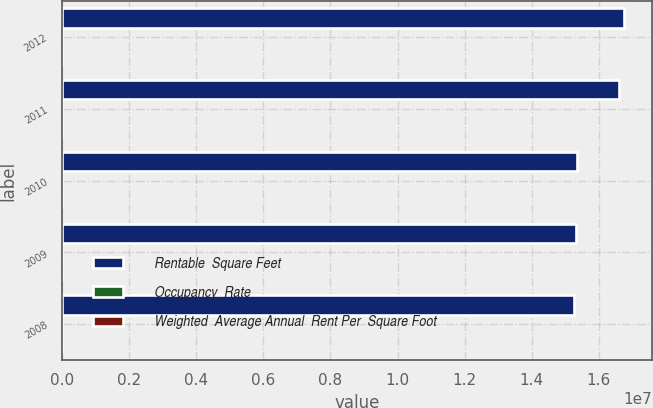Convert chart to OTSL. <chart><loc_0><loc_0><loc_500><loc_500><stacked_bar_chart><ecel><fcel>2012<fcel>2011<fcel>2010<fcel>2009<fcel>2008<nl><fcel>Rentable  Square Feet<fcel>1.6751e+07<fcel>1.6598e+07<fcel>1.5348e+07<fcel>1.5331e+07<fcel>1.5266e+07<nl><fcel>Occupancy  Rate<fcel>95.9<fcel>96.2<fcel>96.1<fcel>97.1<fcel>98<nl><fcel>Weighted  Average Annual  Rent Per  Square Foot<fcel>60.17<fcel>58.7<fcel>56.14<fcel>55.54<fcel>55<nl></chart> 